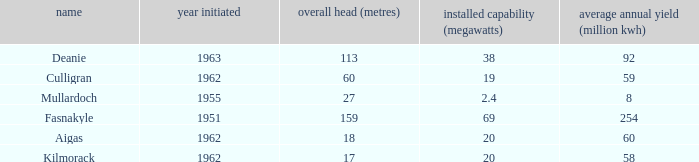What is the earliest Year commissioned wiht an Average annual output greater than 58 and Installed capacity of 20? 1962.0. 